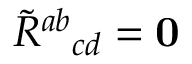<formula> <loc_0><loc_0><loc_500><loc_500>\tilde { R ^ { a b _ { c d } = 0</formula> 